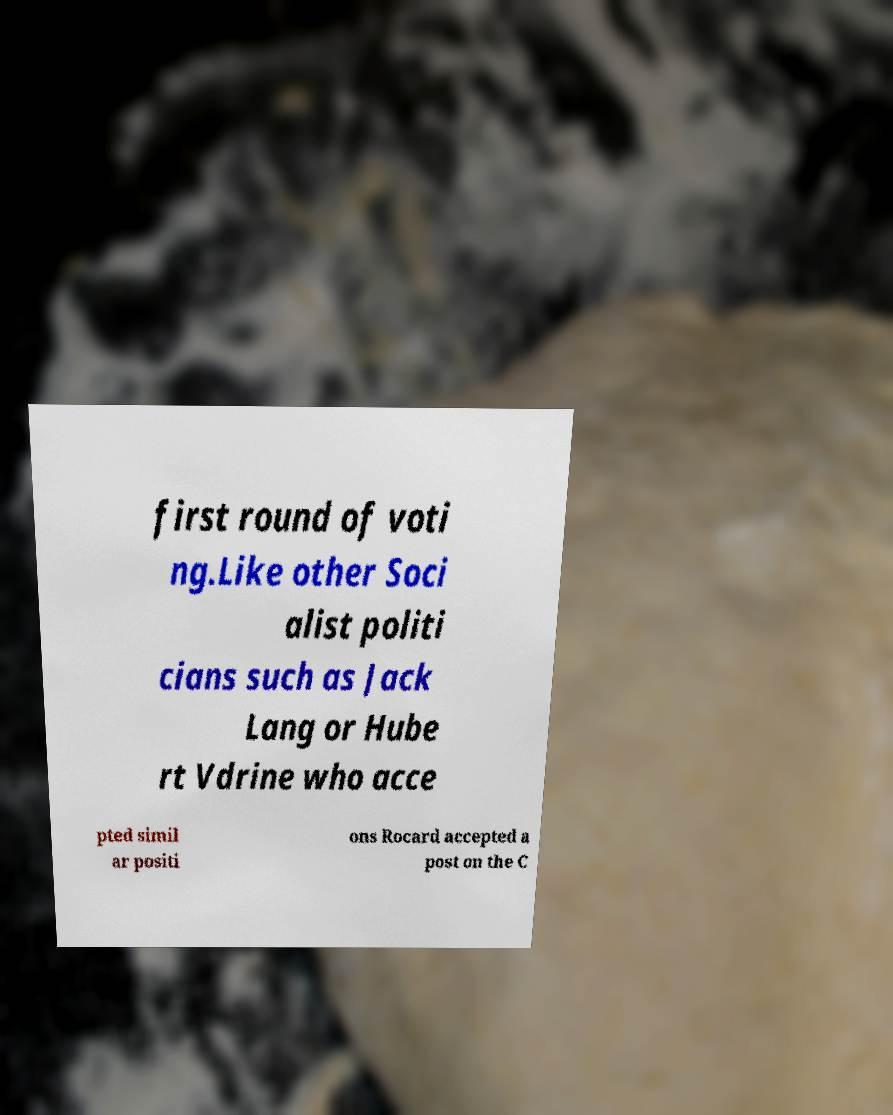I need the written content from this picture converted into text. Can you do that? first round of voti ng.Like other Soci alist politi cians such as Jack Lang or Hube rt Vdrine who acce pted simil ar positi ons Rocard accepted a post on the C 